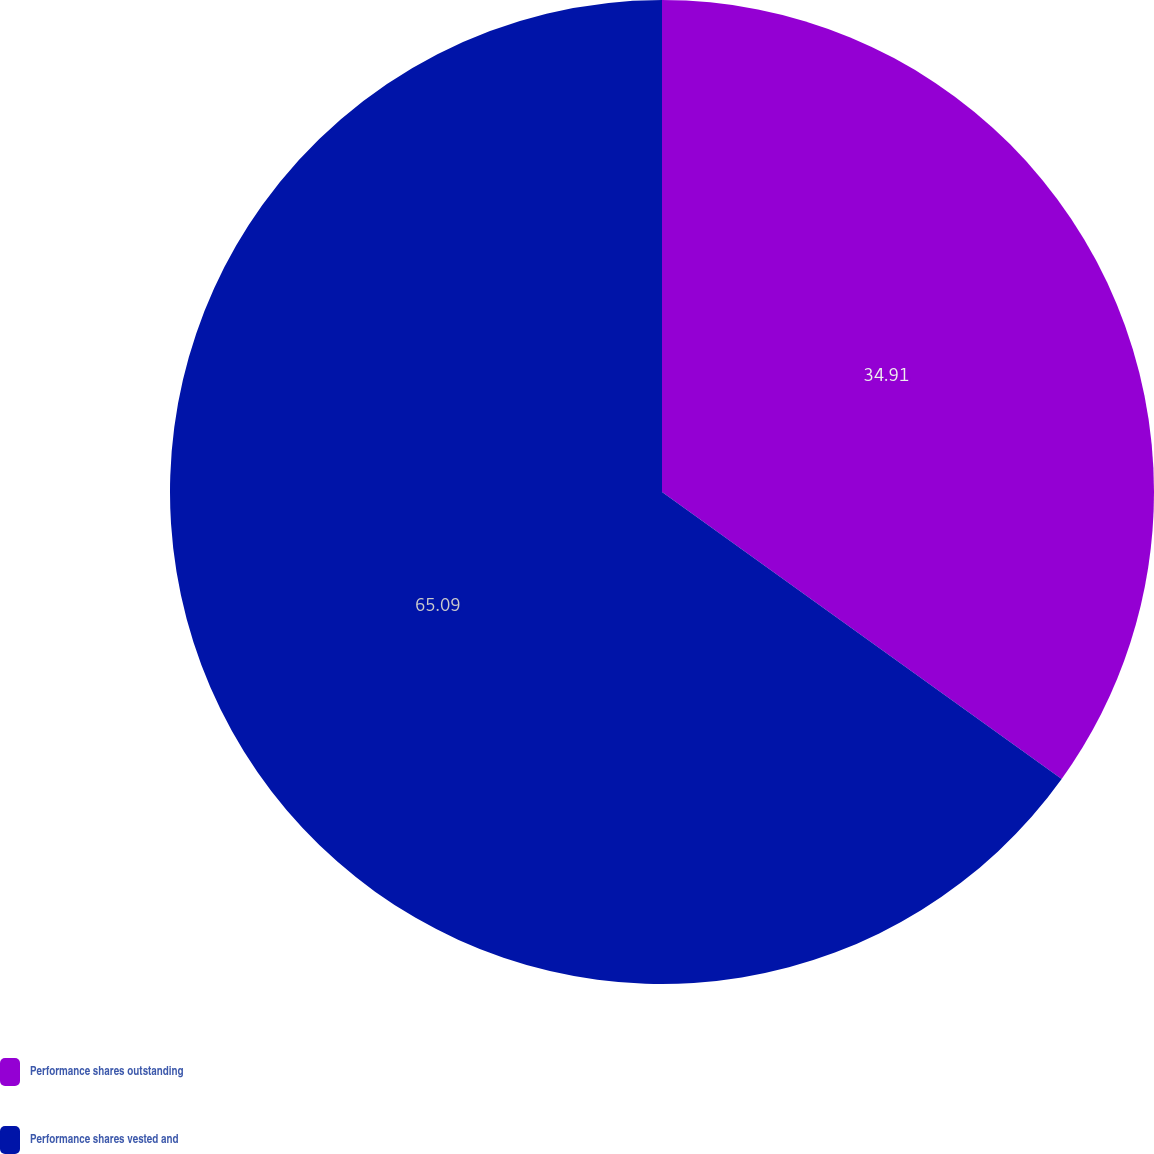<chart> <loc_0><loc_0><loc_500><loc_500><pie_chart><fcel>Performance shares outstanding<fcel>Performance shares vested and<nl><fcel>34.91%<fcel>65.09%<nl></chart> 